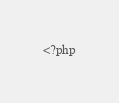<code> <loc_0><loc_0><loc_500><loc_500><_PHP_><?php</code> 